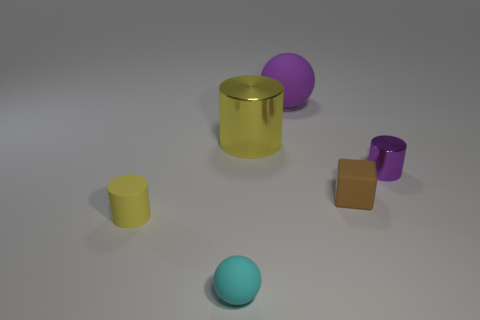Subtract all tiny purple cylinders. How many cylinders are left? 2 Subtract all purple cylinders. How many cylinders are left? 2 Subtract 2 balls. How many balls are left? 0 Add 2 tiny purple rubber things. How many objects exist? 8 Subtract all yellow balls. How many blue cylinders are left? 0 Subtract 0 gray spheres. How many objects are left? 6 Subtract all blocks. How many objects are left? 5 Subtract all blue cylinders. Subtract all green blocks. How many cylinders are left? 3 Subtract all small metallic cylinders. Subtract all small cyan things. How many objects are left? 4 Add 5 brown objects. How many brown objects are left? 6 